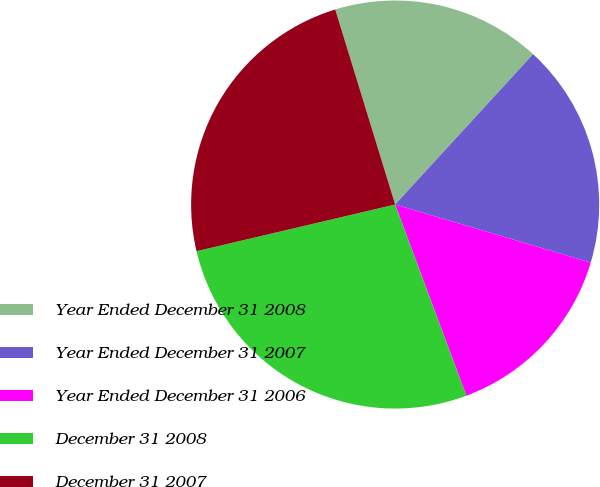<chart> <loc_0><loc_0><loc_500><loc_500><pie_chart><fcel>Year Ended December 31 2008<fcel>Year Ended December 31 2007<fcel>Year Ended December 31 2006<fcel>December 31 2008<fcel>December 31 2007<nl><fcel>16.56%<fcel>17.78%<fcel>14.73%<fcel>27.0%<fcel>23.93%<nl></chart> 